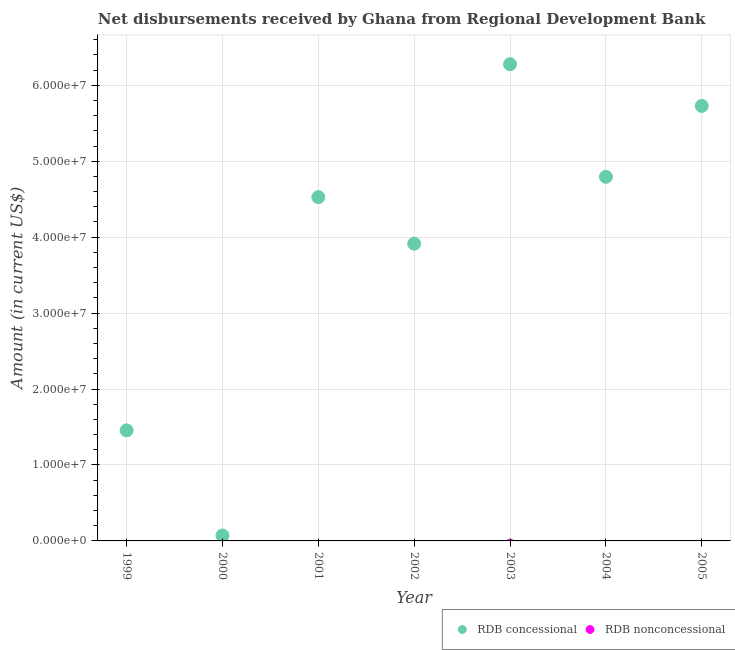How many different coloured dotlines are there?
Keep it short and to the point. 1. What is the net non concessional disbursements from rdb in 1999?
Keep it short and to the point. 0. Across all years, what is the maximum net concessional disbursements from rdb?
Your answer should be compact. 6.28e+07. Across all years, what is the minimum net concessional disbursements from rdb?
Make the answer very short. 7.06e+05. In which year was the net concessional disbursements from rdb maximum?
Give a very brief answer. 2003. What is the total net concessional disbursements from rdb in the graph?
Ensure brevity in your answer.  2.68e+08. What is the difference between the net concessional disbursements from rdb in 2002 and that in 2004?
Your response must be concise. -8.80e+06. What is the difference between the net concessional disbursements from rdb in 1999 and the net non concessional disbursements from rdb in 2004?
Keep it short and to the point. 1.46e+07. What is the average net concessional disbursements from rdb per year?
Make the answer very short. 3.82e+07. In how many years, is the net non concessional disbursements from rdb greater than 40000000 US$?
Offer a terse response. 0. What is the ratio of the net concessional disbursements from rdb in 2002 to that in 2005?
Give a very brief answer. 0.68. What is the difference between the highest and the second highest net concessional disbursements from rdb?
Your answer should be compact. 5.49e+06. What is the difference between the highest and the lowest net concessional disbursements from rdb?
Ensure brevity in your answer.  6.21e+07. Is the sum of the net concessional disbursements from rdb in 2000 and 2005 greater than the maximum net non concessional disbursements from rdb across all years?
Your answer should be very brief. Yes. Are the values on the major ticks of Y-axis written in scientific E-notation?
Offer a terse response. Yes. Does the graph contain grids?
Your response must be concise. Yes. Where does the legend appear in the graph?
Your answer should be very brief. Bottom right. How many legend labels are there?
Your answer should be very brief. 2. How are the legend labels stacked?
Offer a terse response. Horizontal. What is the title of the graph?
Your answer should be compact. Net disbursements received by Ghana from Regional Development Bank. What is the label or title of the Y-axis?
Offer a very short reply. Amount (in current US$). What is the Amount (in current US$) in RDB concessional in 1999?
Ensure brevity in your answer.  1.46e+07. What is the Amount (in current US$) in RDB nonconcessional in 1999?
Keep it short and to the point. 0. What is the Amount (in current US$) in RDB concessional in 2000?
Your answer should be compact. 7.06e+05. What is the Amount (in current US$) of RDB concessional in 2001?
Provide a short and direct response. 4.53e+07. What is the Amount (in current US$) in RDB concessional in 2002?
Your answer should be very brief. 3.91e+07. What is the Amount (in current US$) in RDB concessional in 2003?
Make the answer very short. 6.28e+07. What is the Amount (in current US$) of RDB concessional in 2004?
Make the answer very short. 4.79e+07. What is the Amount (in current US$) of RDB concessional in 2005?
Give a very brief answer. 5.73e+07. Across all years, what is the maximum Amount (in current US$) of RDB concessional?
Provide a short and direct response. 6.28e+07. Across all years, what is the minimum Amount (in current US$) in RDB concessional?
Ensure brevity in your answer.  7.06e+05. What is the total Amount (in current US$) of RDB concessional in the graph?
Provide a succinct answer. 2.68e+08. What is the total Amount (in current US$) in RDB nonconcessional in the graph?
Offer a terse response. 0. What is the difference between the Amount (in current US$) of RDB concessional in 1999 and that in 2000?
Give a very brief answer. 1.39e+07. What is the difference between the Amount (in current US$) in RDB concessional in 1999 and that in 2001?
Provide a succinct answer. -3.07e+07. What is the difference between the Amount (in current US$) in RDB concessional in 1999 and that in 2002?
Your answer should be very brief. -2.46e+07. What is the difference between the Amount (in current US$) of RDB concessional in 1999 and that in 2003?
Give a very brief answer. -4.82e+07. What is the difference between the Amount (in current US$) of RDB concessional in 1999 and that in 2004?
Your answer should be very brief. -3.34e+07. What is the difference between the Amount (in current US$) in RDB concessional in 1999 and that in 2005?
Your response must be concise. -4.27e+07. What is the difference between the Amount (in current US$) in RDB concessional in 2000 and that in 2001?
Ensure brevity in your answer.  -4.46e+07. What is the difference between the Amount (in current US$) in RDB concessional in 2000 and that in 2002?
Keep it short and to the point. -3.84e+07. What is the difference between the Amount (in current US$) in RDB concessional in 2000 and that in 2003?
Provide a short and direct response. -6.21e+07. What is the difference between the Amount (in current US$) of RDB concessional in 2000 and that in 2004?
Ensure brevity in your answer.  -4.72e+07. What is the difference between the Amount (in current US$) in RDB concessional in 2000 and that in 2005?
Your answer should be very brief. -5.66e+07. What is the difference between the Amount (in current US$) in RDB concessional in 2001 and that in 2002?
Offer a terse response. 6.12e+06. What is the difference between the Amount (in current US$) in RDB concessional in 2001 and that in 2003?
Ensure brevity in your answer.  -1.75e+07. What is the difference between the Amount (in current US$) of RDB concessional in 2001 and that in 2004?
Your answer should be compact. -2.68e+06. What is the difference between the Amount (in current US$) in RDB concessional in 2001 and that in 2005?
Your answer should be compact. -1.20e+07. What is the difference between the Amount (in current US$) in RDB concessional in 2002 and that in 2003?
Make the answer very short. -2.36e+07. What is the difference between the Amount (in current US$) of RDB concessional in 2002 and that in 2004?
Your answer should be compact. -8.80e+06. What is the difference between the Amount (in current US$) of RDB concessional in 2002 and that in 2005?
Your answer should be very brief. -1.81e+07. What is the difference between the Amount (in current US$) of RDB concessional in 2003 and that in 2004?
Your answer should be very brief. 1.48e+07. What is the difference between the Amount (in current US$) of RDB concessional in 2003 and that in 2005?
Offer a very short reply. 5.49e+06. What is the difference between the Amount (in current US$) in RDB concessional in 2004 and that in 2005?
Offer a very short reply. -9.34e+06. What is the average Amount (in current US$) of RDB concessional per year?
Ensure brevity in your answer.  3.82e+07. What is the ratio of the Amount (in current US$) of RDB concessional in 1999 to that in 2000?
Ensure brevity in your answer.  20.62. What is the ratio of the Amount (in current US$) of RDB concessional in 1999 to that in 2001?
Provide a short and direct response. 0.32. What is the ratio of the Amount (in current US$) in RDB concessional in 1999 to that in 2002?
Your answer should be very brief. 0.37. What is the ratio of the Amount (in current US$) of RDB concessional in 1999 to that in 2003?
Your response must be concise. 0.23. What is the ratio of the Amount (in current US$) of RDB concessional in 1999 to that in 2004?
Provide a succinct answer. 0.3. What is the ratio of the Amount (in current US$) in RDB concessional in 1999 to that in 2005?
Your answer should be very brief. 0.25. What is the ratio of the Amount (in current US$) in RDB concessional in 2000 to that in 2001?
Ensure brevity in your answer.  0.02. What is the ratio of the Amount (in current US$) in RDB concessional in 2000 to that in 2002?
Your response must be concise. 0.02. What is the ratio of the Amount (in current US$) of RDB concessional in 2000 to that in 2003?
Ensure brevity in your answer.  0.01. What is the ratio of the Amount (in current US$) in RDB concessional in 2000 to that in 2004?
Give a very brief answer. 0.01. What is the ratio of the Amount (in current US$) of RDB concessional in 2000 to that in 2005?
Your answer should be compact. 0.01. What is the ratio of the Amount (in current US$) of RDB concessional in 2001 to that in 2002?
Give a very brief answer. 1.16. What is the ratio of the Amount (in current US$) of RDB concessional in 2001 to that in 2003?
Offer a very short reply. 0.72. What is the ratio of the Amount (in current US$) of RDB concessional in 2001 to that in 2004?
Make the answer very short. 0.94. What is the ratio of the Amount (in current US$) of RDB concessional in 2001 to that in 2005?
Your answer should be compact. 0.79. What is the ratio of the Amount (in current US$) in RDB concessional in 2002 to that in 2003?
Your response must be concise. 0.62. What is the ratio of the Amount (in current US$) in RDB concessional in 2002 to that in 2004?
Your answer should be compact. 0.82. What is the ratio of the Amount (in current US$) in RDB concessional in 2002 to that in 2005?
Give a very brief answer. 0.68. What is the ratio of the Amount (in current US$) of RDB concessional in 2003 to that in 2004?
Your response must be concise. 1.31. What is the ratio of the Amount (in current US$) in RDB concessional in 2003 to that in 2005?
Make the answer very short. 1.1. What is the ratio of the Amount (in current US$) of RDB concessional in 2004 to that in 2005?
Your answer should be very brief. 0.84. What is the difference between the highest and the second highest Amount (in current US$) of RDB concessional?
Offer a very short reply. 5.49e+06. What is the difference between the highest and the lowest Amount (in current US$) of RDB concessional?
Give a very brief answer. 6.21e+07. 